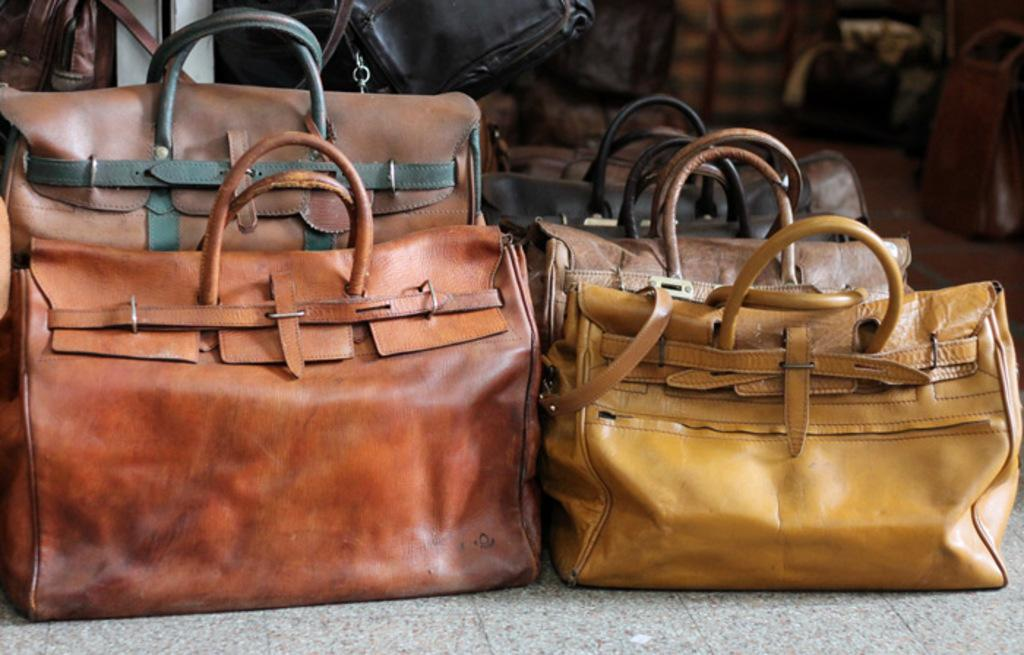What type of handbag is in the image? There is a brown color leather handbag in the image. Can you describe the other handbags in the image? There is a group of handbags in the background of the image. What does the yak believe about the cause of the handbag's color? There is no yak present in the image, and therefore it cannot have any beliefs about the cause of the handbag's color. 